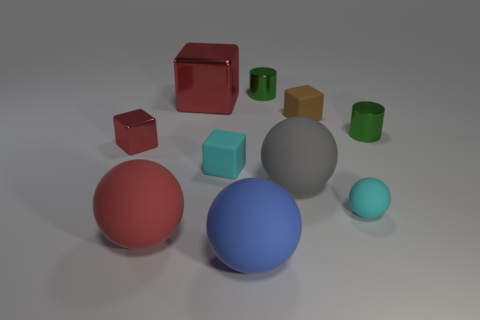What shape is the small metallic thing that is left of the big gray ball and on the right side of the big red cube?
Offer a very short reply. Cylinder. What is the material of the cyan thing behind the large gray object to the left of the small cyan matte sphere?
Offer a very short reply. Rubber. Is the number of gray balls greater than the number of tiny gray matte things?
Give a very brief answer. Yes. Does the large block have the same color as the small metallic cube?
Provide a succinct answer. Yes. There is a gray object that is the same size as the blue thing; what is its material?
Provide a succinct answer. Rubber. Are the brown thing and the big red cube made of the same material?
Provide a short and direct response. No. How many big blue cylinders are made of the same material as the tiny cyan sphere?
Give a very brief answer. 0. How many objects are either green shiny objects that are behind the big red metal block or green shiny things to the right of the gray matte sphere?
Provide a short and direct response. 2. Are there more green shiny things left of the small cyan ball than cubes in front of the blue rubber object?
Provide a succinct answer. Yes. The small thing left of the large red rubber sphere is what color?
Make the answer very short. Red. 